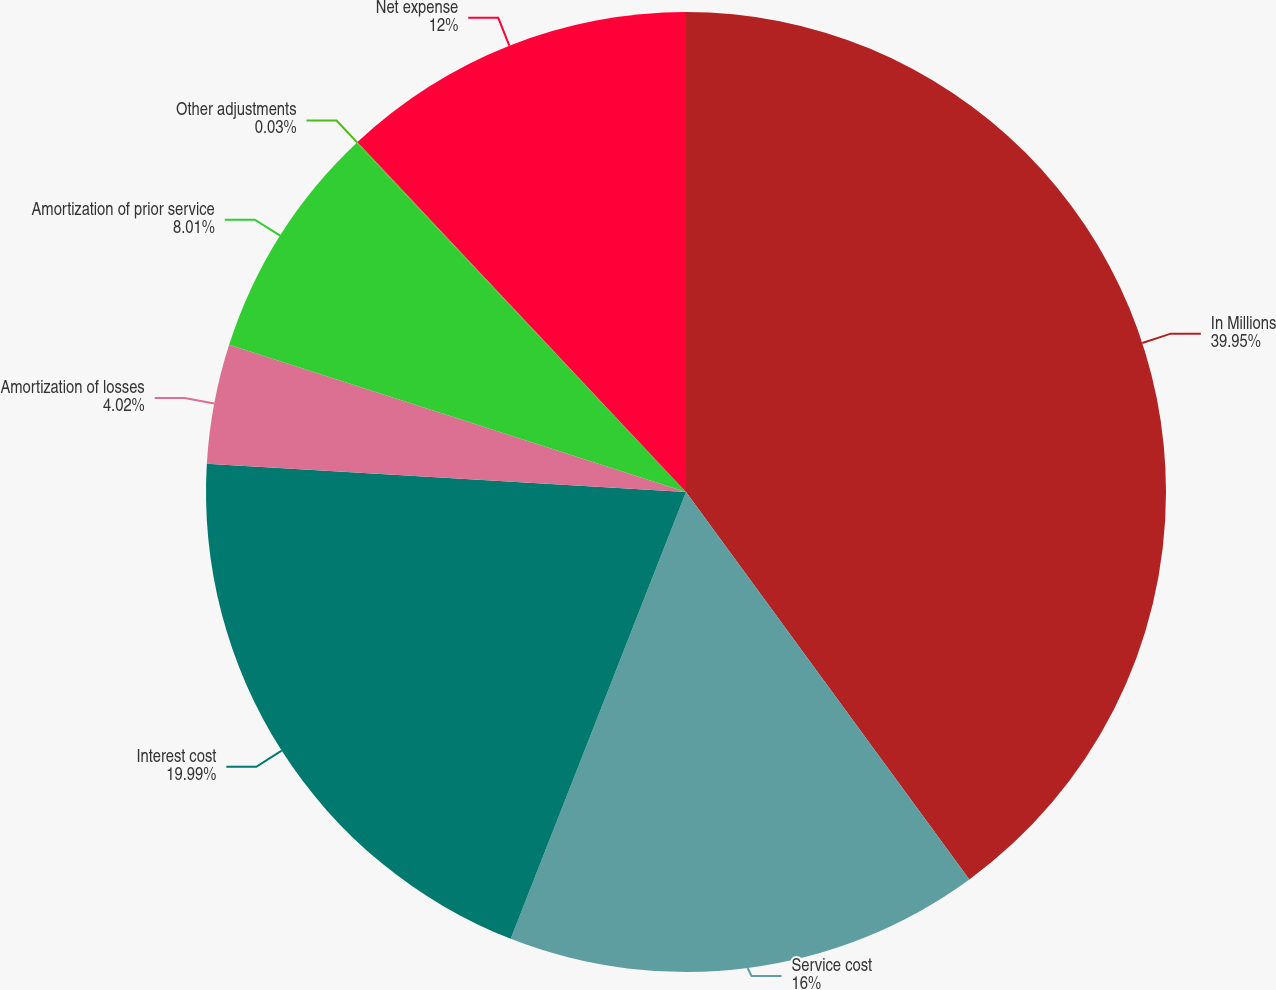Convert chart. <chart><loc_0><loc_0><loc_500><loc_500><pie_chart><fcel>In Millions<fcel>Service cost<fcel>Interest cost<fcel>Amortization of losses<fcel>Amortization of prior service<fcel>Other adjustments<fcel>Net expense<nl><fcel>39.95%<fcel>16.0%<fcel>19.99%<fcel>4.02%<fcel>8.01%<fcel>0.03%<fcel>12.0%<nl></chart> 